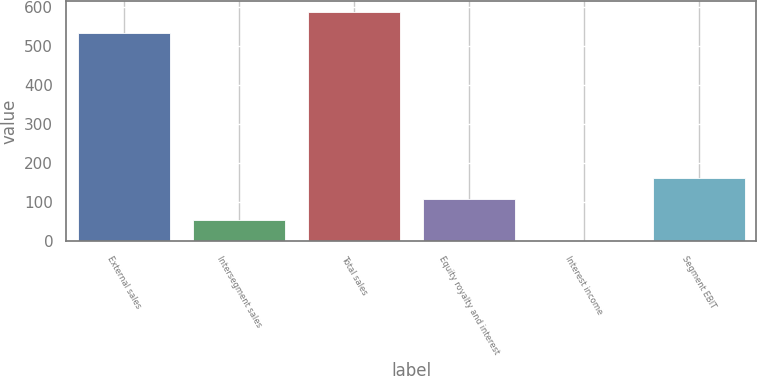<chart> <loc_0><loc_0><loc_500><loc_500><bar_chart><fcel>External sales<fcel>Intersegment sales<fcel>Total sales<fcel>Equity royalty and interest<fcel>Interest income<fcel>Segment EBIT<nl><fcel>534<fcel>54.9<fcel>587.9<fcel>108.8<fcel>1<fcel>162.7<nl></chart> 